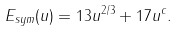<formula> <loc_0><loc_0><loc_500><loc_500>E _ { s y m } ( u ) = 1 3 u ^ { 2 / 3 } + 1 7 u ^ { c } .</formula> 